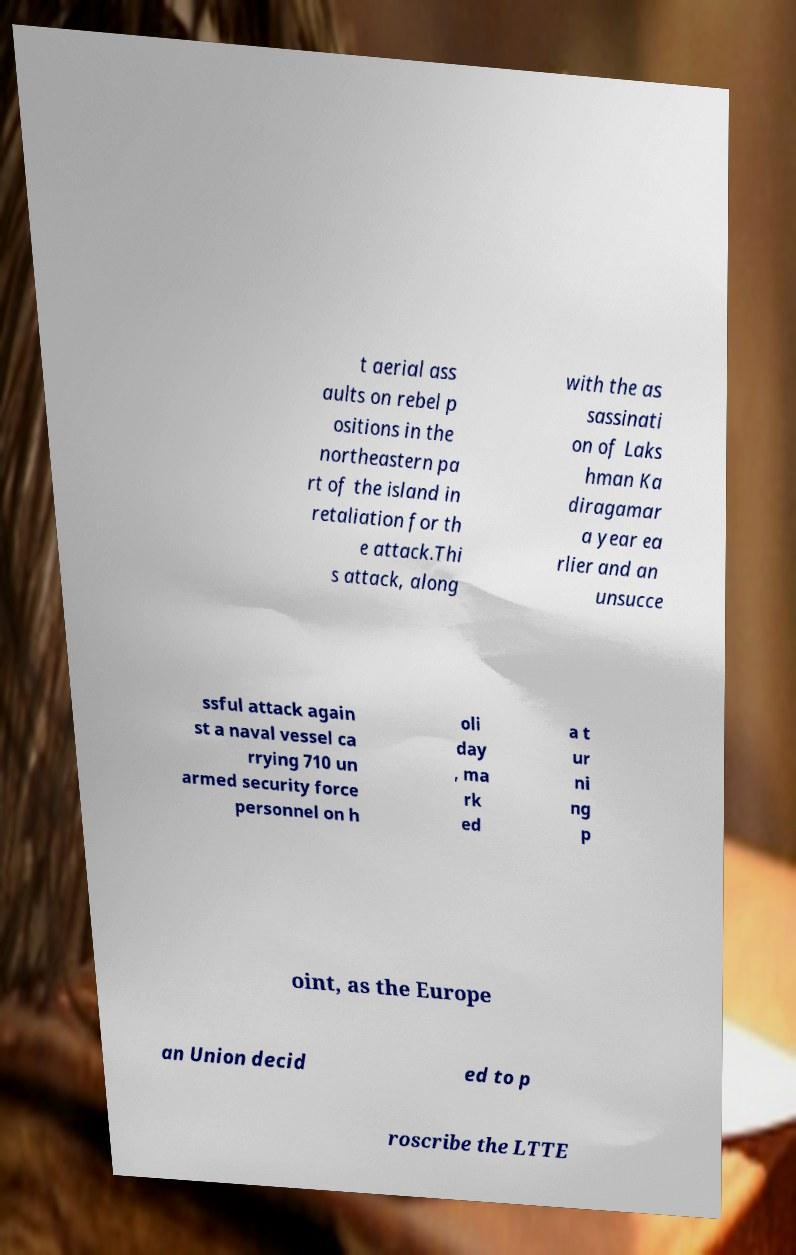For documentation purposes, I need the text within this image transcribed. Could you provide that? t aerial ass aults on rebel p ositions in the northeastern pa rt of the island in retaliation for th e attack.Thi s attack, along with the as sassinati on of Laks hman Ka diragamar a year ea rlier and an unsucce ssful attack again st a naval vessel ca rrying 710 un armed security force personnel on h oli day , ma rk ed a t ur ni ng p oint, as the Europe an Union decid ed to p roscribe the LTTE 